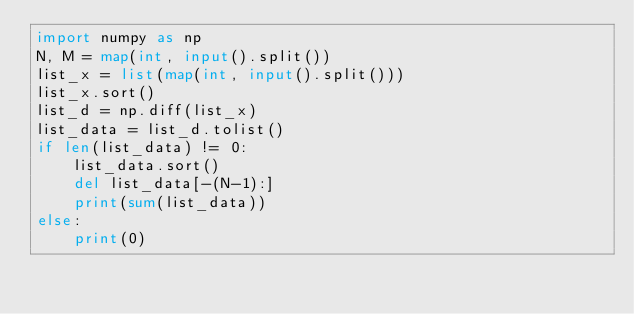Convert code to text. <code><loc_0><loc_0><loc_500><loc_500><_Python_>import numpy as np
N, M = map(int, input().split())
list_x = list(map(int, input().split()))
list_x.sort()
list_d = np.diff(list_x)
list_data = list_d.tolist()
if len(list_data) != 0:
    list_data.sort()
    del list_data[-(N-1):]
    print(sum(list_data))
else:
    print(0)
</code> 